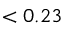Convert formula to latex. <formula><loc_0><loc_0><loc_500><loc_500>< 0 . 2 3</formula> 